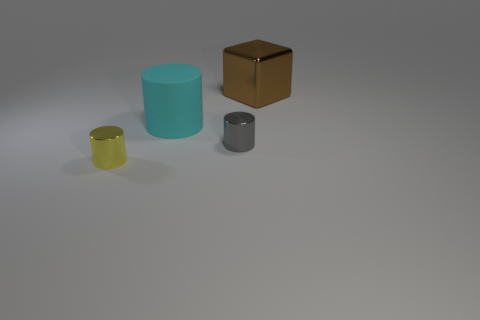How many tiny gray cylinders are the same material as the tiny gray thing?
Offer a very short reply. 0. There is a large metal cube; is its color the same as the small metallic thing that is on the right side of the small yellow object?
Your answer should be very brief. No. There is a block on the right side of the big thing that is to the left of the large brown metallic cube; what is its color?
Provide a succinct answer. Brown. There is another shiny cylinder that is the same size as the gray metal cylinder; what is its color?
Give a very brief answer. Yellow. Are there any blue rubber things of the same shape as the brown thing?
Your answer should be compact. No. What is the shape of the big brown metallic thing?
Give a very brief answer. Cube. Are there more yellow cylinders that are on the left side of the rubber thing than brown cubes to the left of the gray metallic cylinder?
Make the answer very short. Yes. How many other objects are there of the same size as the rubber cylinder?
Offer a very short reply. 1. There is a thing that is behind the small gray shiny thing and to the left of the brown cube; what material is it?
Your answer should be compact. Rubber. There is another tiny object that is the same shape as the gray thing; what is its material?
Your response must be concise. Metal. 